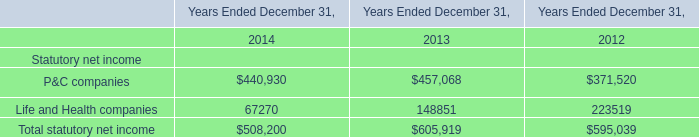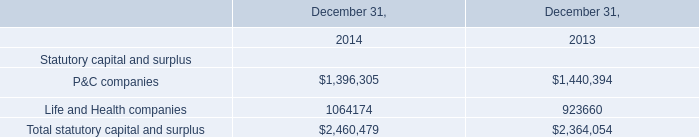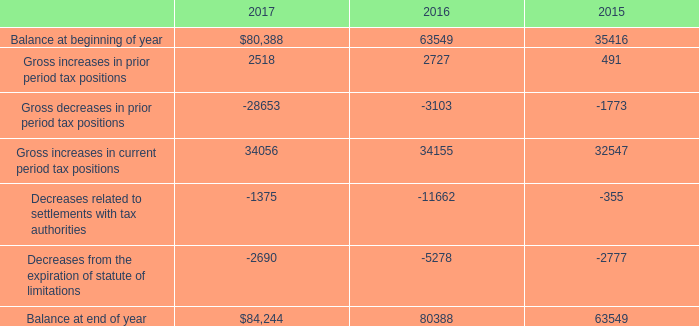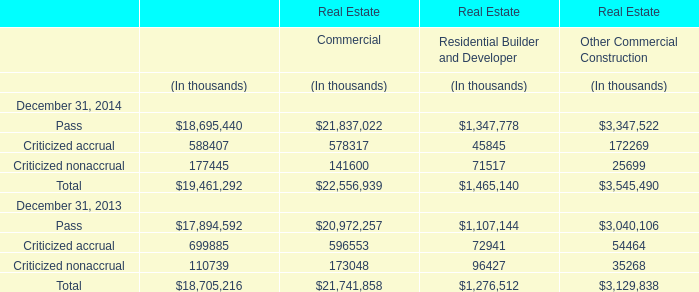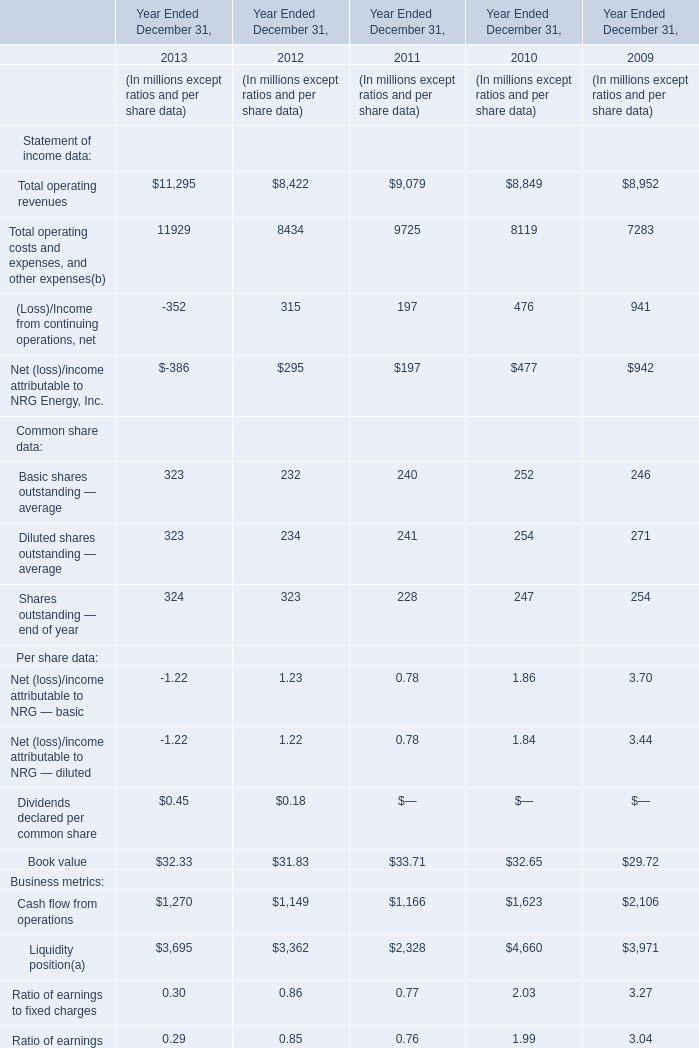What is the total amount of Life and Health companies of Years Ended December 31, 2012, and Balance at end of year of 2015 ? 
Computations: (223519.0 + 63549.0)
Answer: 287068.0. 